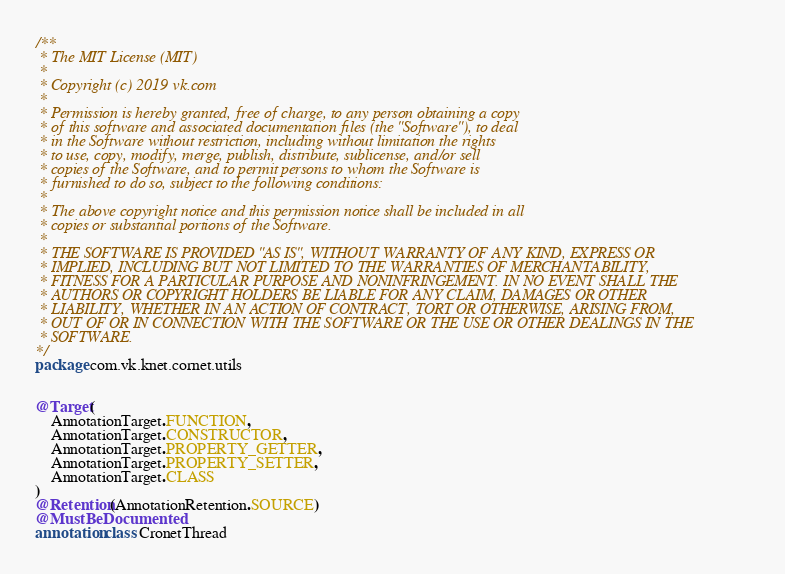Convert code to text. <code><loc_0><loc_0><loc_500><loc_500><_Kotlin_>/**
 * The MIT License (MIT)
 *
 * Copyright (c) 2019 vk.com
 *
 * Permission is hereby granted, free of charge, to any person obtaining a copy
 * of this software and associated documentation files (the "Software"), to deal
 * in the Software without restriction, including without limitation the rights
 * to use, copy, modify, merge, publish, distribute, sublicense, and/or sell
 * copies of the Software, and to permit persons to whom the Software is
 * furnished to do so, subject to the following conditions:
 *
 * The above copyright notice and this permission notice shall be included in all
 * copies or substantial portions of the Software.
 *
 * THE SOFTWARE IS PROVIDED "AS IS", WITHOUT WARRANTY OF ANY KIND, EXPRESS OR
 * IMPLIED, INCLUDING BUT NOT LIMITED TO THE WARRANTIES OF MERCHANTABILITY,
 * FITNESS FOR A PARTICULAR PURPOSE AND NONINFRINGEMENT. IN NO EVENT SHALL THE
 * AUTHORS OR COPYRIGHT HOLDERS BE LIABLE FOR ANY CLAIM, DAMAGES OR OTHER
 * LIABILITY, WHETHER IN AN ACTION OF CONTRACT, TORT OR OTHERWISE, ARISING FROM,
 * OUT OF OR IN CONNECTION WITH THE SOFTWARE OR THE USE OR OTHER DEALINGS IN THE
 * SOFTWARE.
*/
package com.vk.knet.cornet.utils


@Target(
    AnnotationTarget.FUNCTION,
    AnnotationTarget.CONSTRUCTOR,
    AnnotationTarget.PROPERTY_GETTER,
    AnnotationTarget.PROPERTY_SETTER,
    AnnotationTarget.CLASS
)
@Retention(AnnotationRetention.SOURCE)
@MustBeDocumented
annotation class CronetThread</code> 